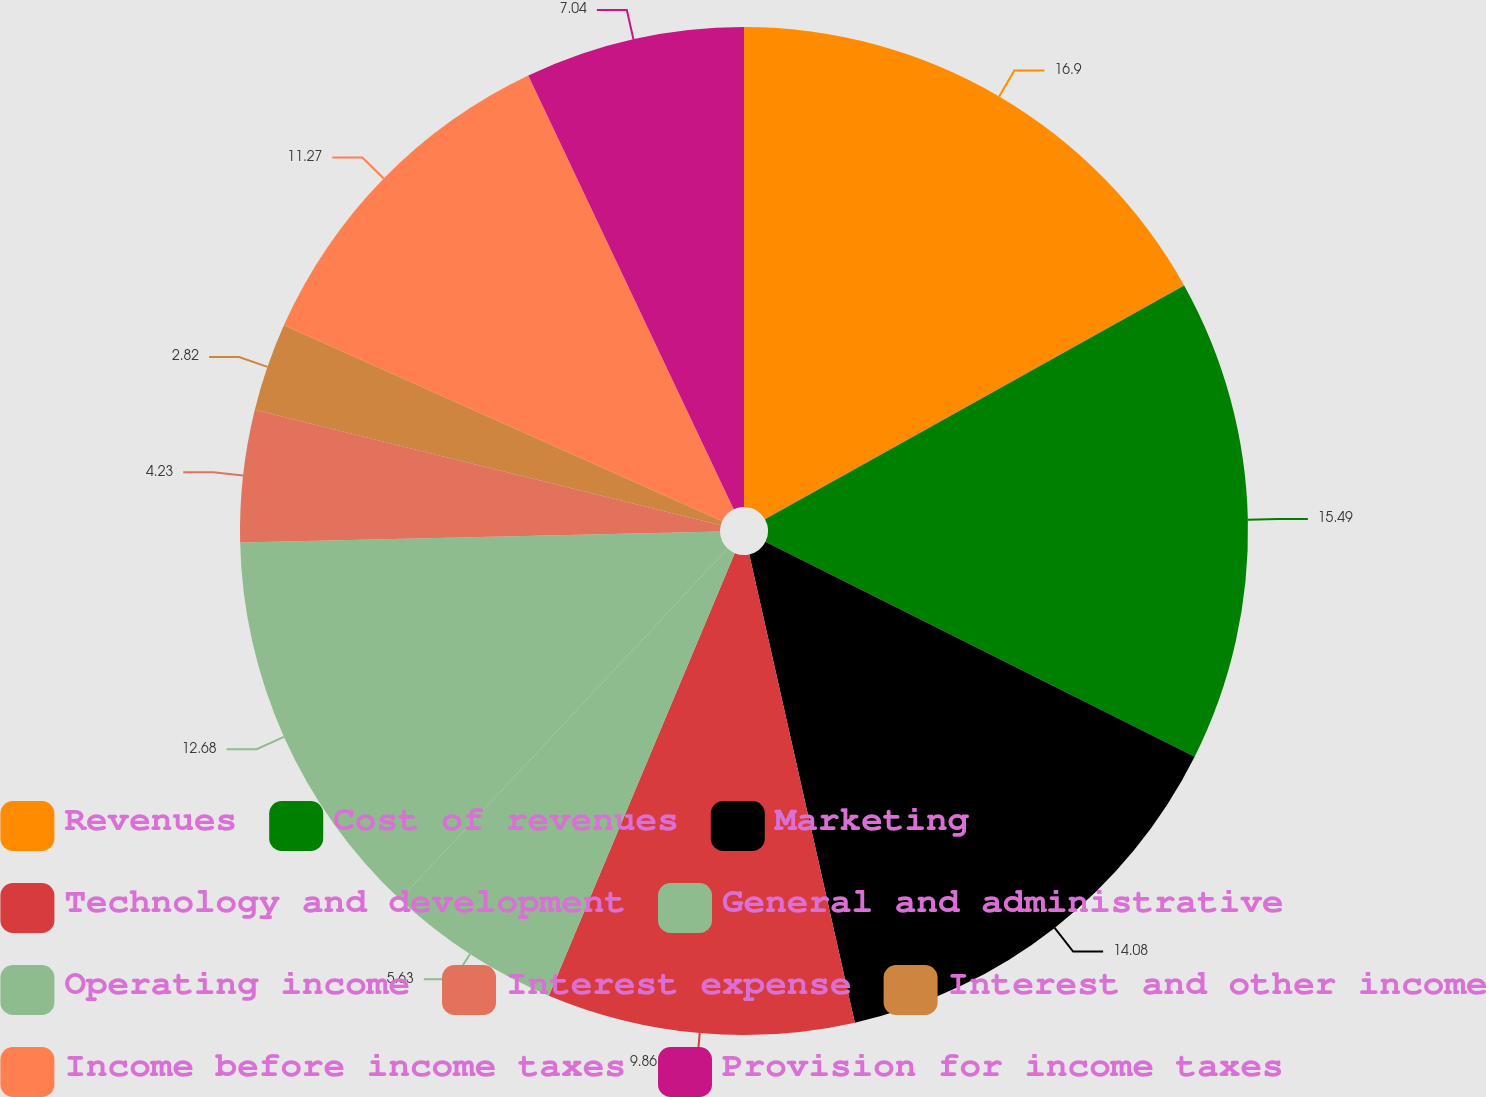<chart> <loc_0><loc_0><loc_500><loc_500><pie_chart><fcel>Revenues<fcel>Cost of revenues<fcel>Marketing<fcel>Technology and development<fcel>General and administrative<fcel>Operating income<fcel>Interest expense<fcel>Interest and other income<fcel>Income before income taxes<fcel>Provision for income taxes<nl><fcel>16.9%<fcel>15.49%<fcel>14.08%<fcel>9.86%<fcel>5.63%<fcel>12.68%<fcel>4.23%<fcel>2.82%<fcel>11.27%<fcel>7.04%<nl></chart> 